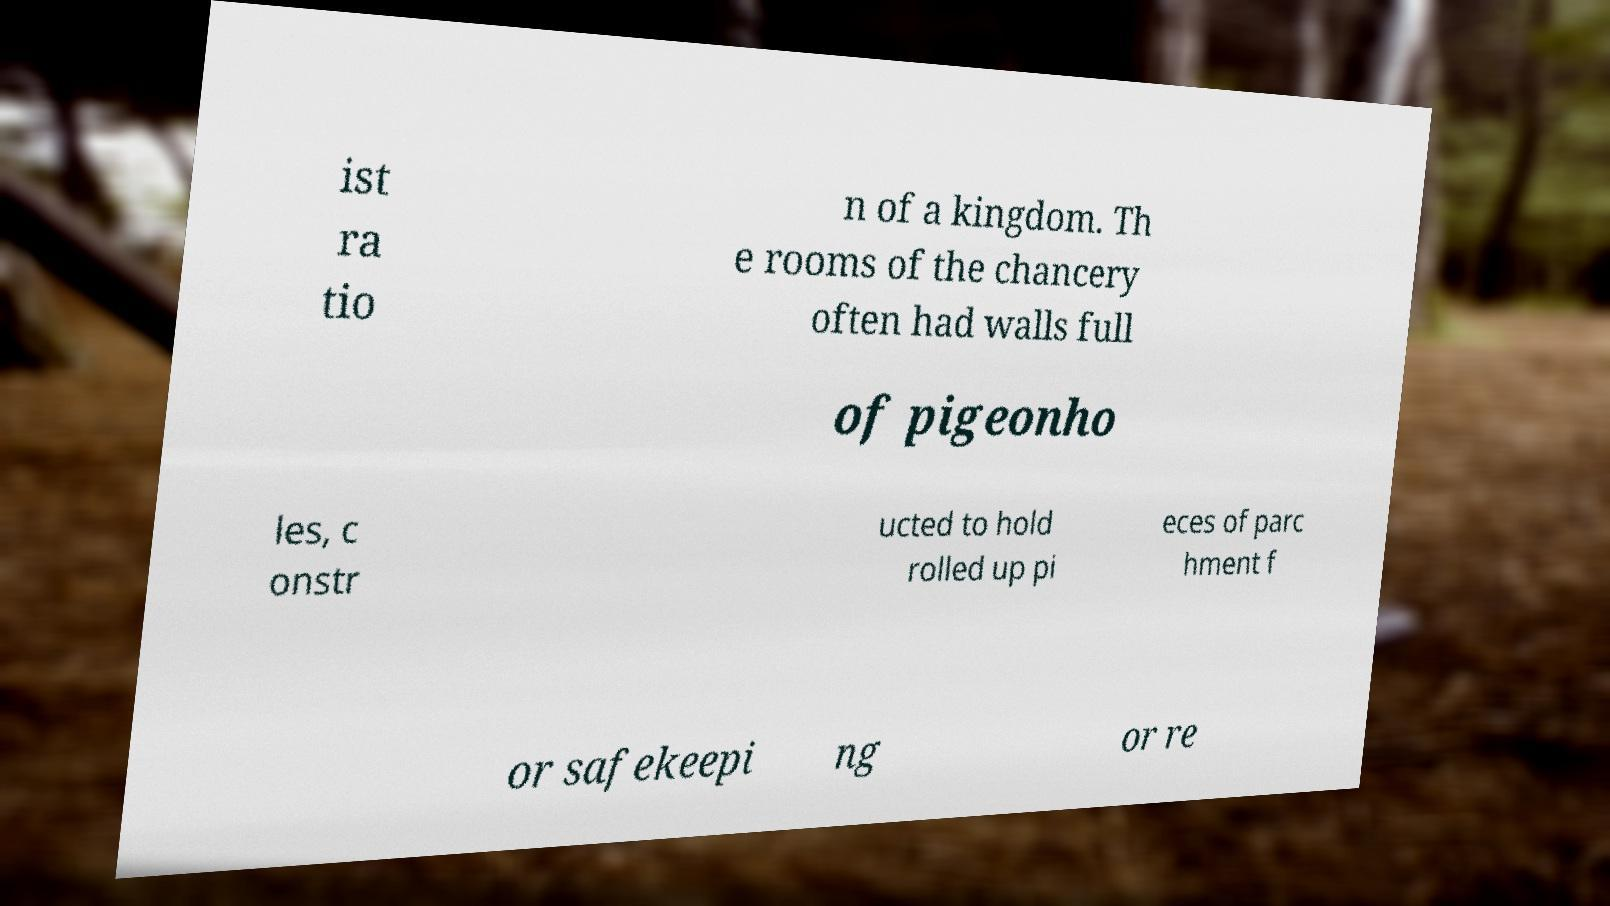Could you extract and type out the text from this image? ist ra tio n of a kingdom. Th e rooms of the chancery often had walls full of pigeonho les, c onstr ucted to hold rolled up pi eces of parc hment f or safekeepi ng or re 